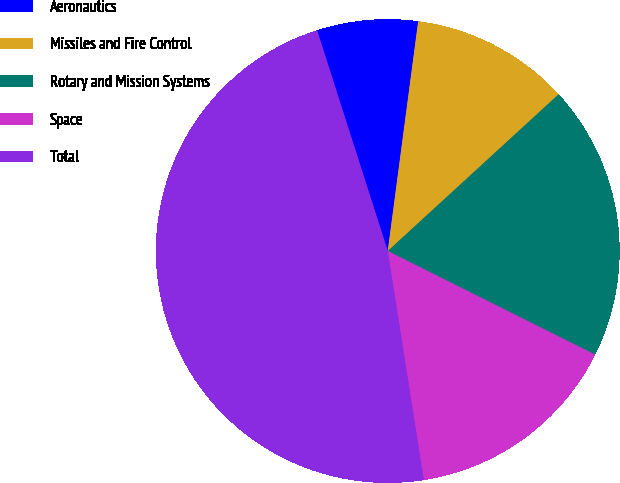<chart> <loc_0><loc_0><loc_500><loc_500><pie_chart><fcel>Aeronautics<fcel>Missiles and Fire Control<fcel>Rotary and Mission Systems<fcel>Space<fcel>Total<nl><fcel>7.03%<fcel>11.09%<fcel>19.19%<fcel>15.14%<fcel>47.55%<nl></chart> 